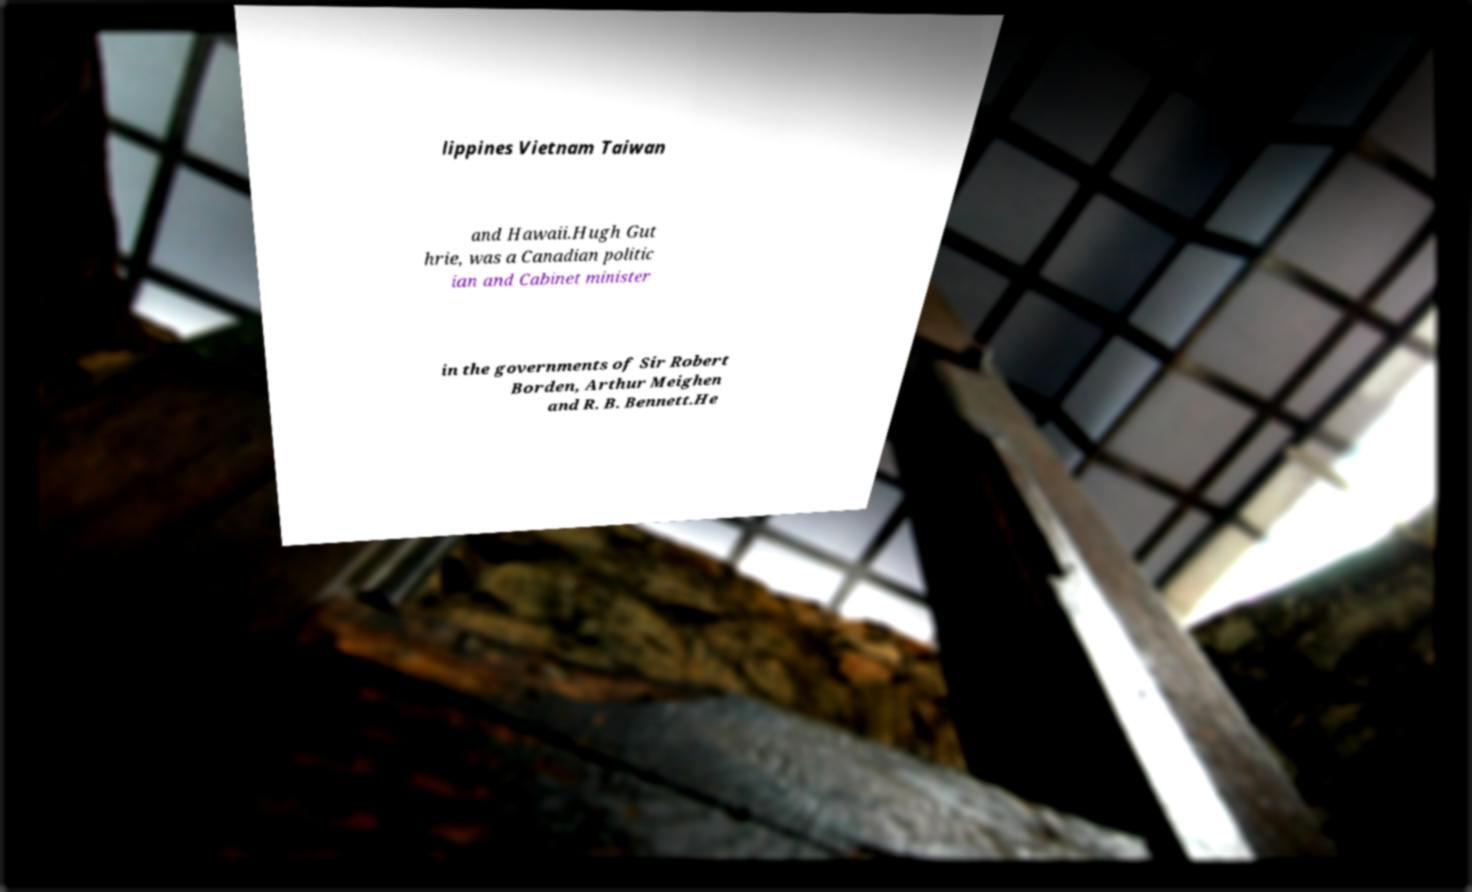I need the written content from this picture converted into text. Can you do that? lippines Vietnam Taiwan and Hawaii.Hugh Gut hrie, was a Canadian politic ian and Cabinet minister in the governments of Sir Robert Borden, Arthur Meighen and R. B. Bennett.He 